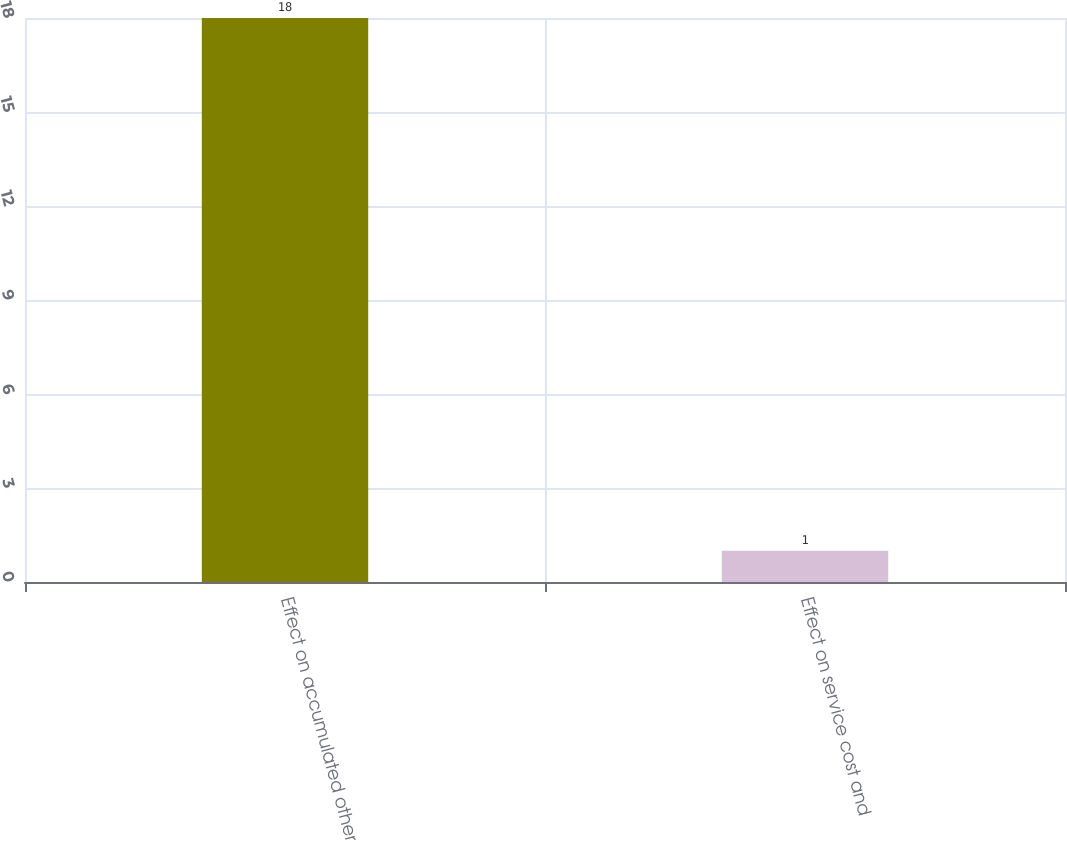<chart> <loc_0><loc_0><loc_500><loc_500><bar_chart><fcel>Effect on accumulated other<fcel>Effect on service cost and<nl><fcel>18<fcel>1<nl></chart> 